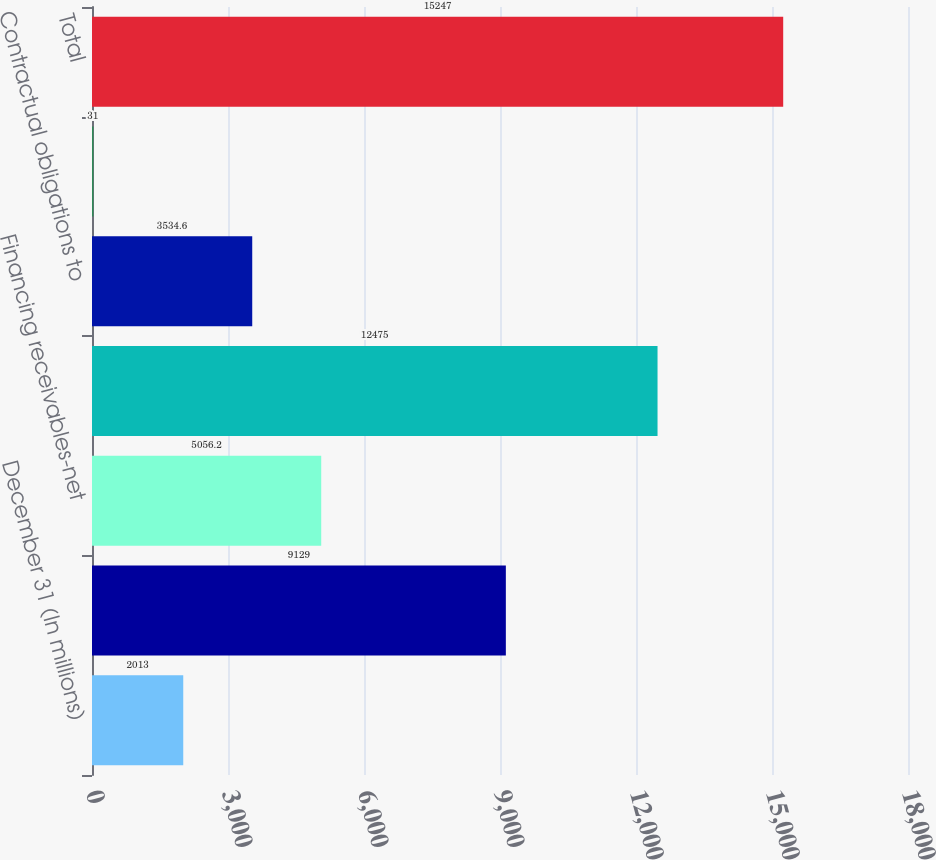<chart> <loc_0><loc_0><loc_500><loc_500><bar_chart><fcel>December 31 (In millions)<fcel>Other assets and investment<fcel>Financing receivables-net<fcel>Total investments<fcel>Contractual obligations to<fcel>Revolving lines of credit<fcel>Total<nl><fcel>2013<fcel>9129<fcel>5056.2<fcel>12475<fcel>3534.6<fcel>31<fcel>15247<nl></chart> 